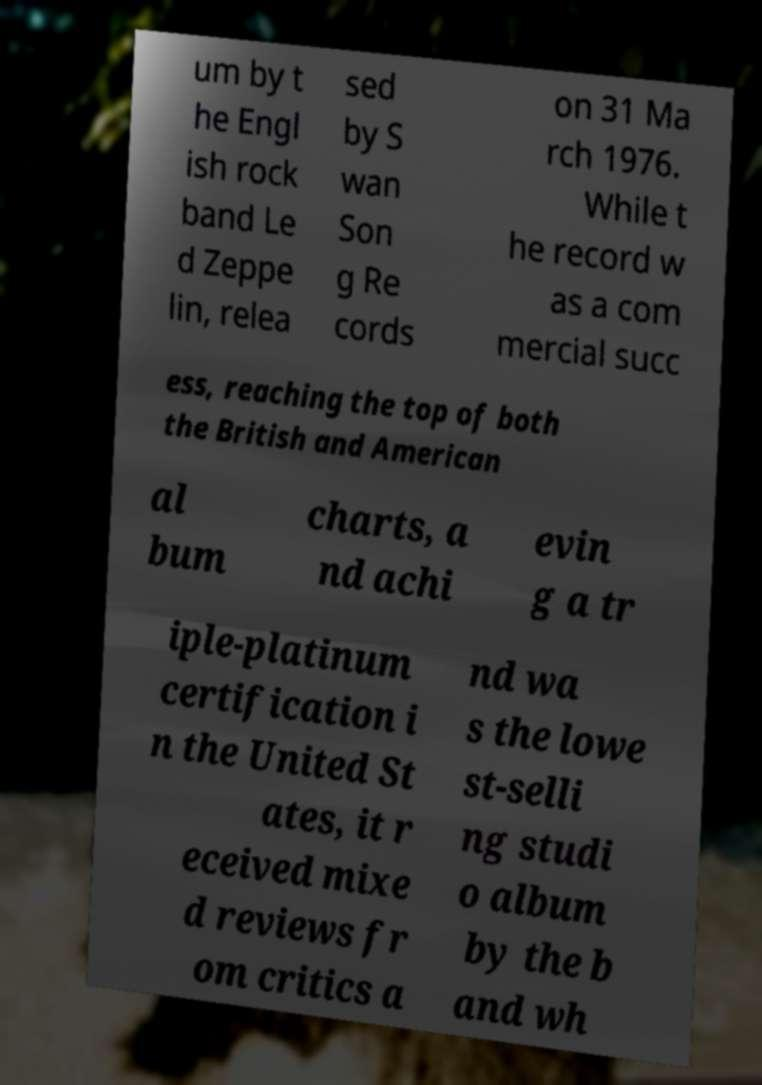Please read and relay the text visible in this image. What does it say? um by t he Engl ish rock band Le d Zeppe lin, relea sed by S wan Son g Re cords on 31 Ma rch 1976. While t he record w as a com mercial succ ess, reaching the top of both the British and American al bum charts, a nd achi evin g a tr iple-platinum certification i n the United St ates, it r eceived mixe d reviews fr om critics a nd wa s the lowe st-selli ng studi o album by the b and wh 